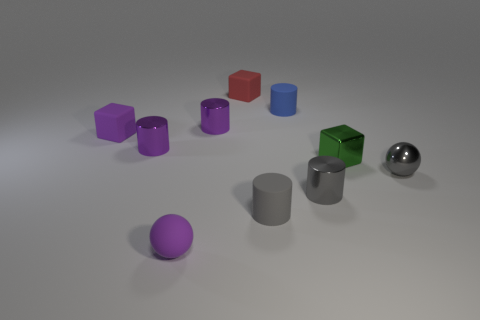The shiny thing that is in front of the green block and to the left of the tiny gray ball is what color?
Your answer should be very brief. Gray. There is a gray metal thing that is in front of the gray metal sphere; does it have the same size as the tiny green metal block?
Provide a succinct answer. Yes. Are there any tiny gray objects in front of the cube that is left of the red rubber object?
Offer a very short reply. Yes. What material is the tiny gray ball?
Provide a short and direct response. Metal. There is a small purple ball; are there any tiny blue matte objects on the left side of it?
Offer a terse response. No. What size is the gray matte object that is the same shape as the small blue object?
Provide a short and direct response. Small. Are there the same number of matte things that are behind the small gray shiny cylinder and balls in front of the red thing?
Offer a terse response. No. How many tiny blue rubber cylinders are there?
Your response must be concise. 1. Are there more blue cylinders in front of the gray metal cylinder than tiny gray metallic spheres?
Ensure brevity in your answer.  No. There is a blue object behind the small rubber ball; what is it made of?
Provide a succinct answer. Rubber. 